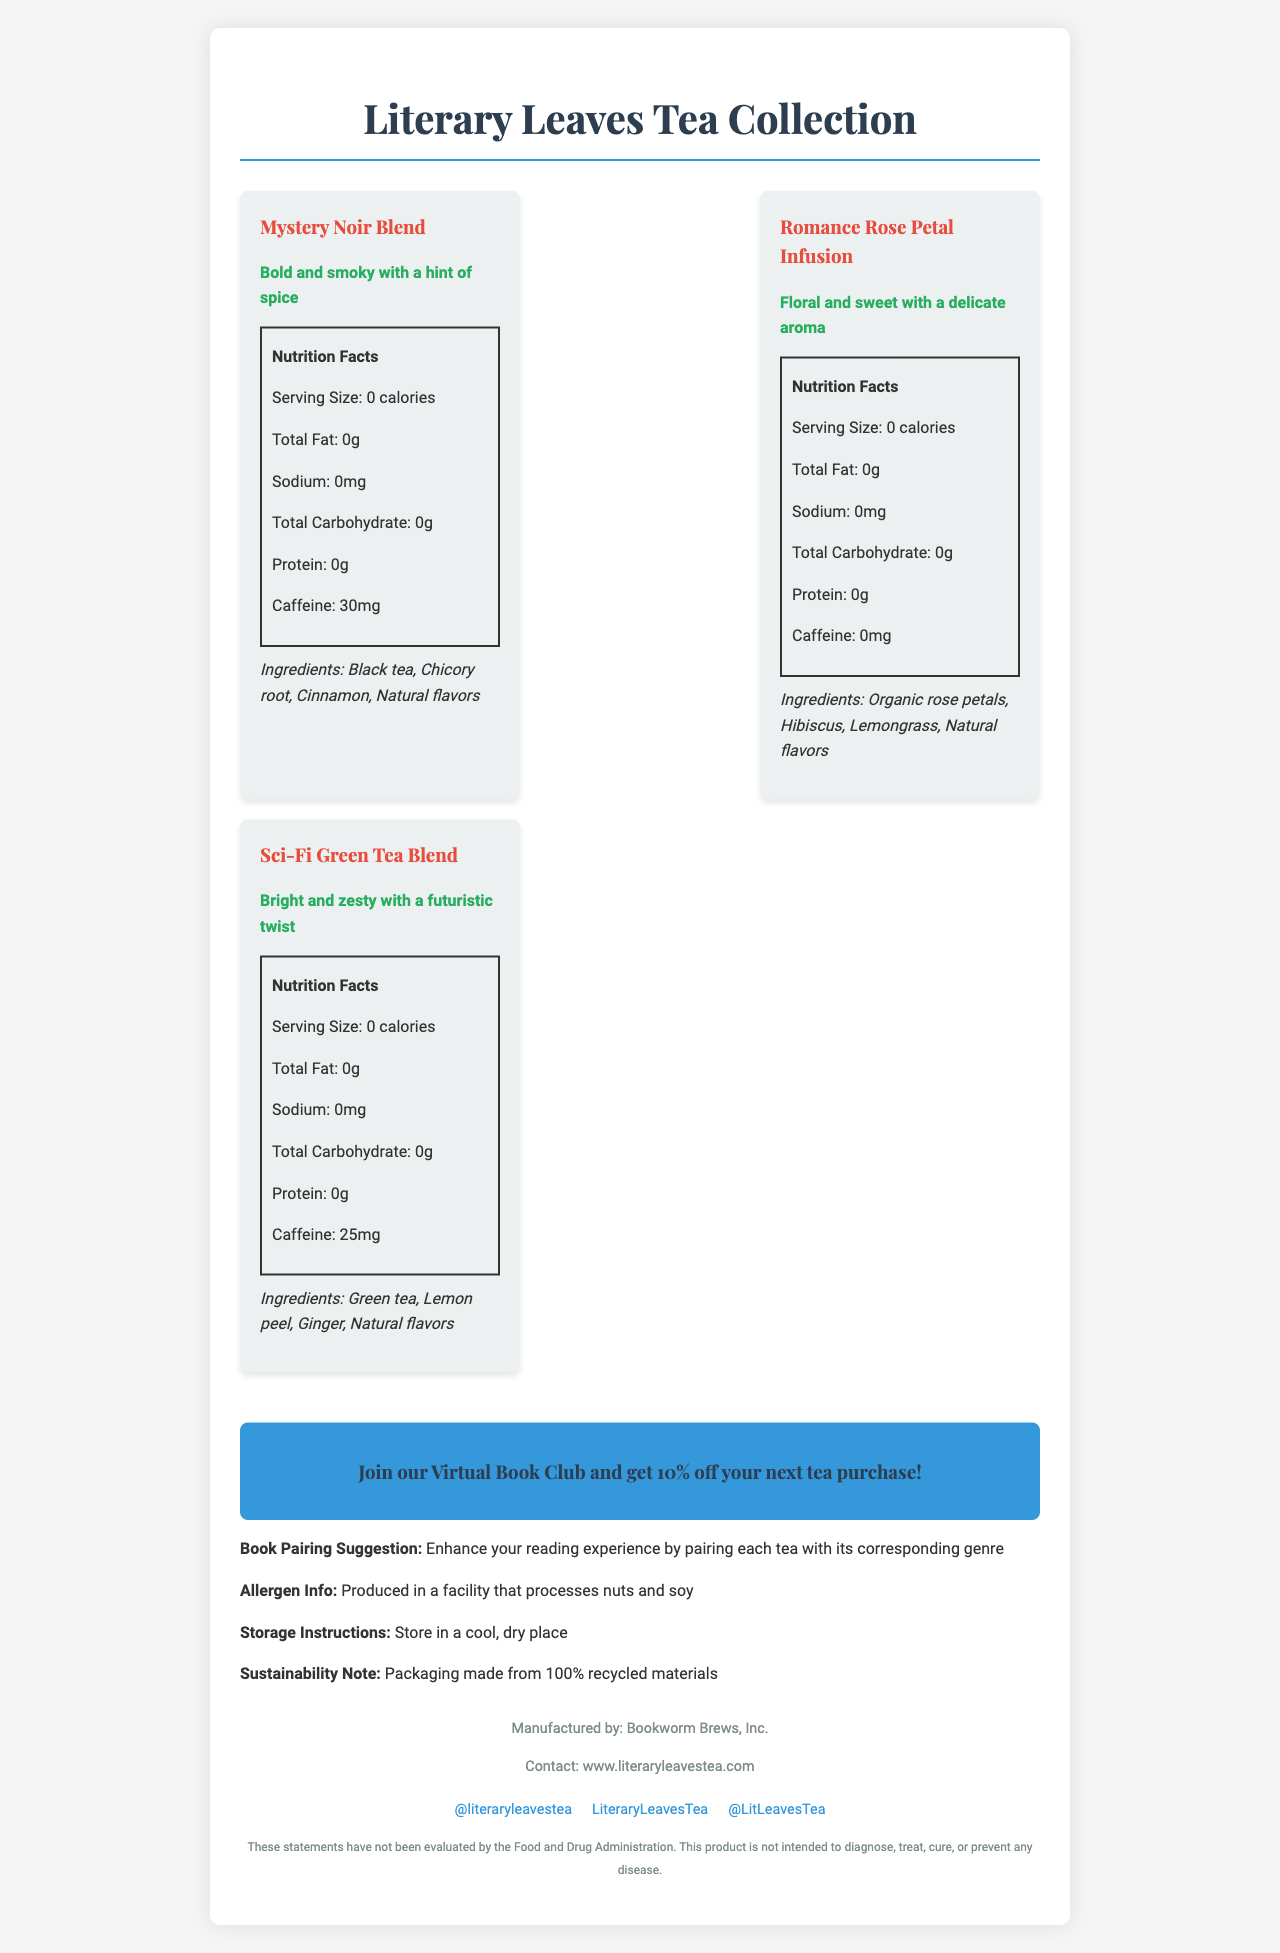what is the product name? The product name is clearly displayed at the top of the document.
Answer: Literary Leaves Tea Collection how many servings are there per container? The document states that there are 20 servings per container.
Answer: 20 what is the serving size for the tea? The serving size is listed as 1 tea bag (2g) in the document.
Answer: 1 tea bag (2g) which genre has the highest caffeine content? The document indicates that the Mystery Noir Blend has 30mg of caffeine, which is the highest among the listed genres.
Answer: Mystery Noir Blend what are the ingredients of the Romance Rose Petal Infusion? The ingredients are listed under the Romance Rose Petal Infusion section in the document.
Answer: Organic rose petals, Hibiscus, Lemongrass, Natural flavors which social media platform has the handle @literaryleavestea? The document mentions that @literaryleavestea is the Instagram handle.
Answer: Instagram can the Literary Leaves Tea Collection treat or cure any diseases? The disclaimer clearly states that the product is not intended to diagnose, treat, cure, or prevent any disease.
Answer: No which genre has no caffeine? A. Mystery Noir Blend B. Romance Rose Petal Infusion C. Sci-Fi Green Tea Blend The Romance Rose Petal Infusion has 0mg of caffeine, making it caffeine-free.
Answer: B what is the flavor profile of Sci-Fi Green Tea Blend? The document describes the flavor profile of the Sci-Fi Green Tea Blend in the relevant section.
Answer: Bright and zesty with a futuristic twist what is the recommended storage method for this tea? A. Refrigerate B. Store in a cool, dry place C. Keep in direct sunlight The storage instructions state to store the tea in a cool, dry place.
Answer: B is the packaging of this tea environmentally friendly? The document mentions that the packaging is made from 100% recycled materials, suggesting environmental friendliness.
Answer: Yes what is the manufacturer's name for the Literary Leaves Tea Collection? The manufacturer is listed as Bookworm Brews, Inc. in the document.
Answer: Bookworm Brews, Inc. which ingredient is common in both Mystery Noir Blend and Sci-Fi Green Tea Blend? Both blends list "Natural flavors" as an ingredient.
Answer: Natural flavors can we determine the price of the Literary Leaves Tea Collection from the document? The document does not provide any pricing details.
Answer: Not enough information summarize the main points of the document. The summary includes the main elements of the document, such as the tea varieties, manufacturer, sustainability note, and special promotions.
Answer: The Literary Leaves Tea Collection is a selection of teas inspired by different book genres, each with unique ingredients and flavor profiles. The collection includes Mystery Noir Blend, Romance Rose Petal Infusion, and Sci-Fi Green Tea Blend. The product is manufactured by Bookworm Brews, Inc., comes in eco-friendly packaging, and is promoted through social media and book club discounts. does the product contain any allergens? The document indicates that the product is produced in a facility that processes nuts and soy, which may be allergens for some people.
Answer: Yes 